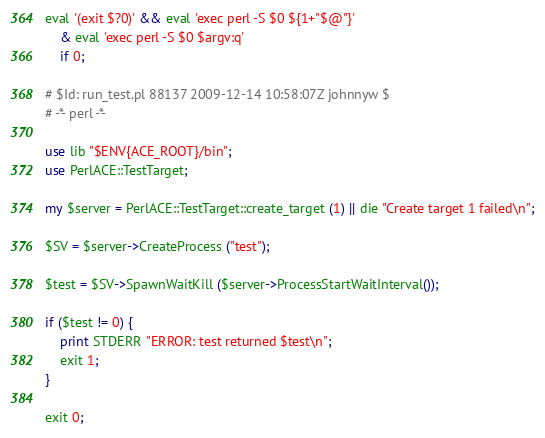<code> <loc_0><loc_0><loc_500><loc_500><_Perl_>eval '(exit $?0)' && eval 'exec perl -S $0 ${1+"$@"}'
    & eval 'exec perl -S $0 $argv:q'
    if 0;

# $Id: run_test.pl 88137 2009-12-14 10:58:07Z johnnyw $
# -*- perl -*-

use lib "$ENV{ACE_ROOT}/bin";
use PerlACE::TestTarget;

my $server = PerlACE::TestTarget::create_target (1) || die "Create target 1 failed\n";

$SV = $server->CreateProcess ("test");

$test = $SV->SpawnWaitKill ($server->ProcessStartWaitInterval());

if ($test != 0) {
    print STDERR "ERROR: test returned $test\n";
    exit 1;
}

exit 0;

</code> 